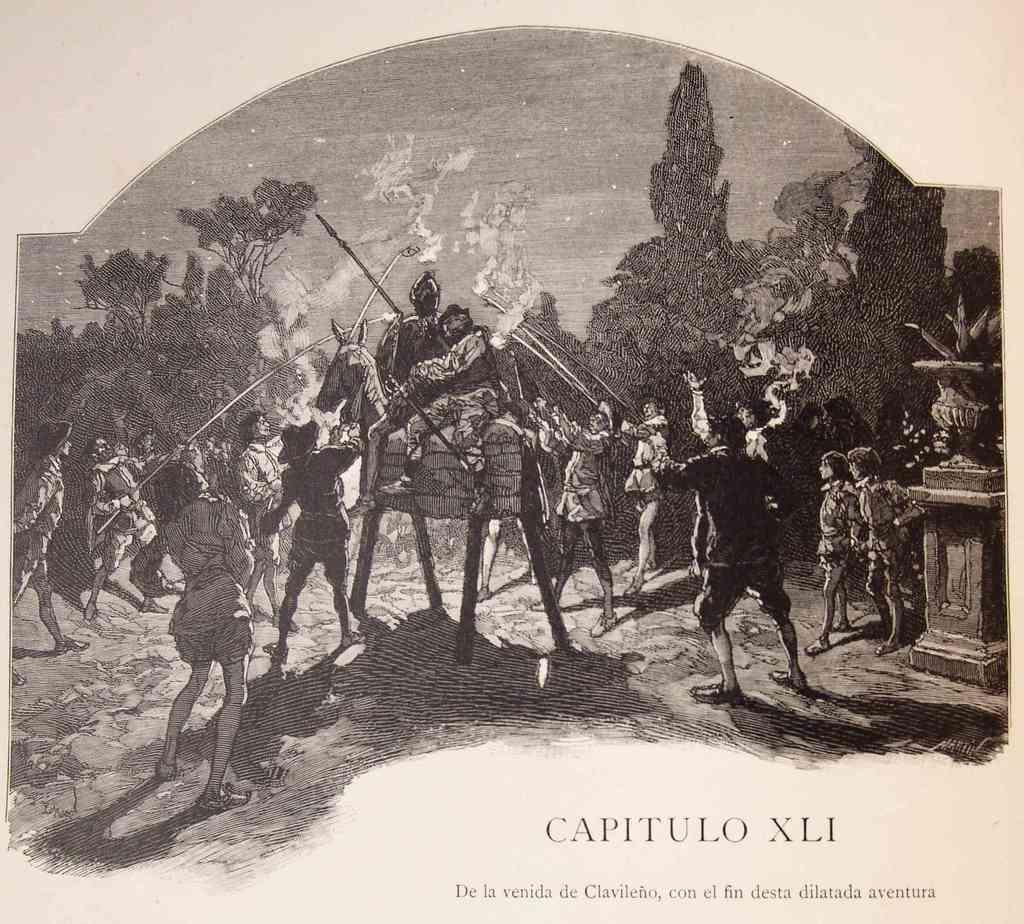What is the main subject of the image? There is a group of people in the image. What can be seen in the background of the image? There are trees in the background of the image. Is there any text or writing visible in the image? Yes, there is text or writing visible in the image. How many planes can be seen flying over the group of people in the image? There are no planes visible in the image. What type of patch is being sewn onto the clothing of the people in the image? There is no patch visible on the clothing of the people in the image. 